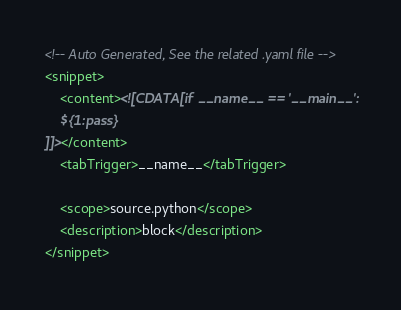<code> <loc_0><loc_0><loc_500><loc_500><_XML_>
<!-- Auto Generated, See the related .yaml file -->
<snippet>
    <content><![CDATA[if __name__ == '__main__':
	${1:pass}
]]></content>
    <tabTrigger>__name__</tabTrigger>

    <scope>source.python</scope>
    <description>block</description>
</snippet></code> 